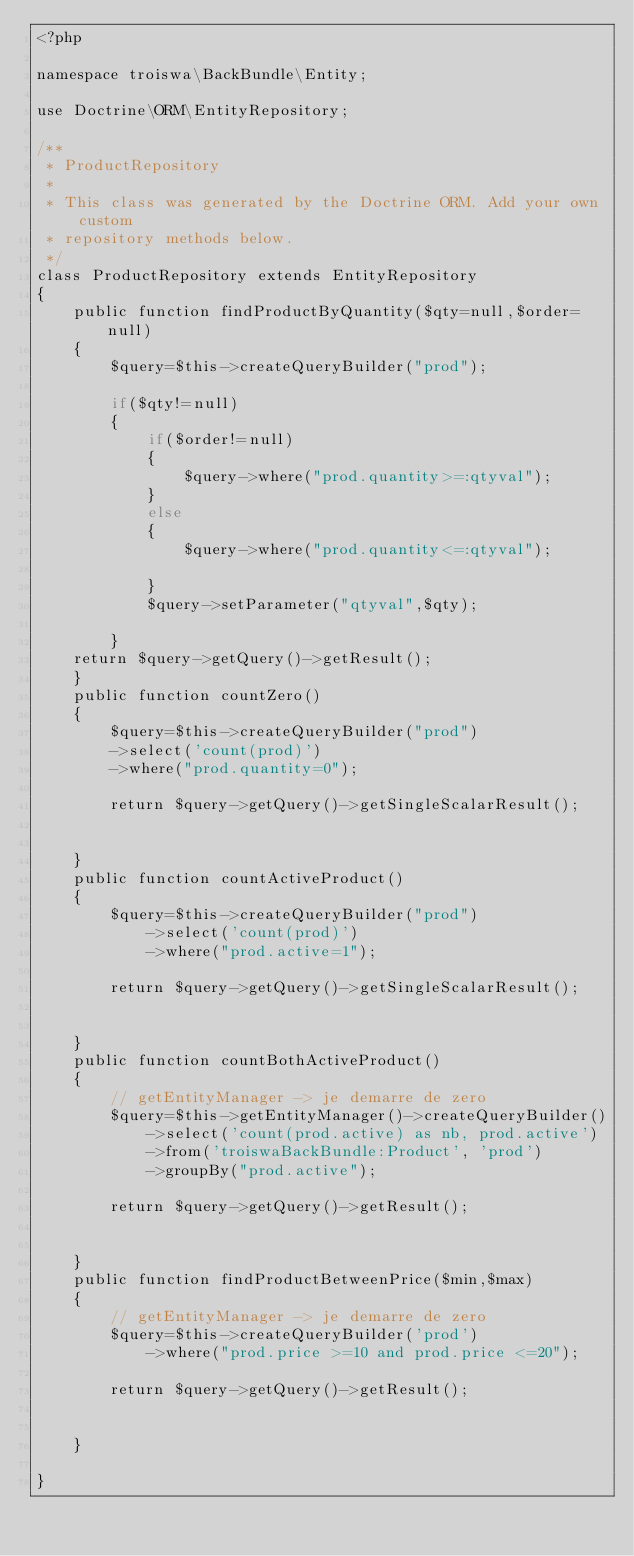<code> <loc_0><loc_0><loc_500><loc_500><_PHP_><?php

namespace troiswa\BackBundle\Entity;

use Doctrine\ORM\EntityRepository;

/**
 * ProductRepository
 *
 * This class was generated by the Doctrine ORM. Add your own custom
 * repository methods below.
 */
class ProductRepository extends EntityRepository
{
    public function findProductByQuantity($qty=null,$order=null)
    {
        $query=$this->createQueryBuilder("prod");

        if($qty!=null)
        {
            if($order!=null)
            {
                $query->where("prod.quantity>=:qtyval");
            }
            else
            {
                $query->where("prod.quantity<=:qtyval");

            }
            $query->setParameter("qtyval",$qty);

        }
    return $query->getQuery()->getResult();
    }
    public function countZero()
    {
        $query=$this->createQueryBuilder("prod")
        ->select('count(prod)')
        ->where("prod.quantity=0");

        return $query->getQuery()->getSingleScalarResult();


    }
    public function countActiveProduct()
    {
        $query=$this->createQueryBuilder("prod")
            ->select('count(prod)')
            ->where("prod.active=1");

        return $query->getQuery()->getSingleScalarResult();


    }
    public function countBothActiveProduct()
    {
        // getEntityManager -> je demarre de zero
        $query=$this->getEntityManager()->createQueryBuilder()
            ->select('count(prod.active) as nb, prod.active')
            ->from('troiswaBackBundle:Product', 'prod')
            ->groupBy("prod.active");

        return $query->getQuery()->getResult();


    }
    public function findProductBetweenPrice($min,$max)
    {
        // getEntityManager -> je demarre de zero
        $query=$this->createQueryBuilder('prod')
            ->where("prod.price >=10 and prod.price <=20");

        return $query->getQuery()->getResult();


    }

}
</code> 